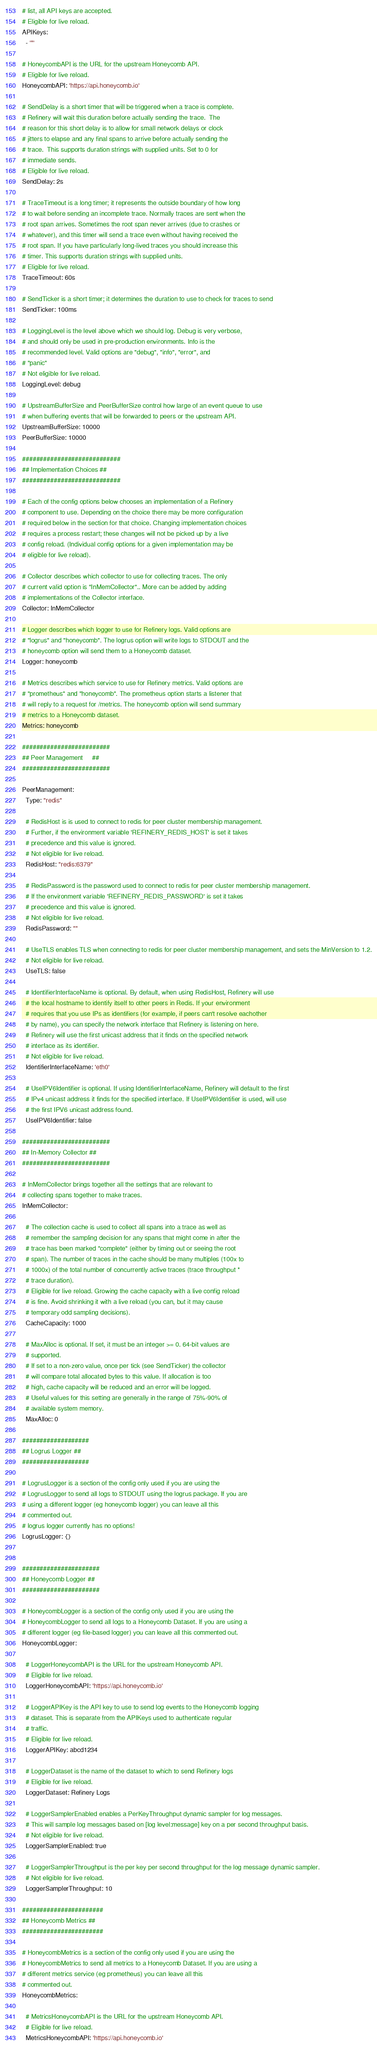Convert code to text. <code><loc_0><loc_0><loc_500><loc_500><_YAML_># list, all API keys are accepted.
# Eligible for live reload.
APIKeys:
  - '*'

# HoneycombAPI is the URL for the upstream Honeycomb API.
# Eligible for live reload.
HoneycombAPI: 'https://api.honeycomb.io'

# SendDelay is a short timer that will be triggered when a trace is complete.
# Refinery will wait this duration before actually sending the trace.  The
# reason for this short delay is to allow for small network delays or clock
# jitters to elapse and any final spans to arrive before actually sending the
# trace.  This supports duration strings with supplied units. Set to 0 for
# immediate sends.
# Eligible for live reload.
SendDelay: 2s

# TraceTimeout is a long timer; it represents the outside boundary of how long
# to wait before sending an incomplete trace. Normally traces are sent when the
# root span arrives. Sometimes the root span never arrives (due to crashes or
# whatever), and this timer will send a trace even without having received the
# root span. If you have particularly long-lived traces you should increase this
# timer. This supports duration strings with supplied units.
# Eligible for live reload.
TraceTimeout: 60s

# SendTicker is a short timer; it determines the duration to use to check for traces to send
SendTicker: 100ms

# LoggingLevel is the level above which we should log. Debug is very verbose,
# and should only be used in pre-production environments. Info is the
# recommended level. Valid options are "debug", "info", "error", and
# "panic"
# Not eligible for live reload.
LoggingLevel: debug

# UpstreamBufferSize and PeerBufferSize control how large of an event queue to use
# when buffering events that will be forwarded to peers or the upstream API.
UpstreamBufferSize: 10000
PeerBufferSize: 10000

############################
## Implementation Choices ##
############################

# Each of the config options below chooses an implementation of a Refinery
# component to use. Depending on the choice there may be more configuration
# required below in the section for that choice. Changing implementation choices
# requires a process restart; these changes will not be picked up by a live
# config reload. (Individual config options for a given implementation may be
# eligible for live reload).

# Collector describes which collector to use for collecting traces. The only
# current valid option is "InMemCollector".. More can be added by adding
# implementations of the Collector interface.
Collector: InMemCollector

# Logger describes which logger to use for Refinery logs. Valid options are
# "logrus" and "honeycomb". The logrus option will write logs to STDOUT and the
# honeycomb option will send them to a Honeycomb dataset.
Logger: honeycomb

# Metrics describes which service to use for Refinery metrics. Valid options are
# "prometheus" and "honeycomb". The prometheus option starts a listener that
# will reply to a request for /metrics. The honeycomb option will send summary
# metrics to a Honeycomb dataset.
Metrics: honeycomb

#########################
## Peer Management     ##
#########################

PeerManagement:
  Type: "redis"

  # RedisHost is is used to connect to redis for peer cluster membership management.
  # Further, if the environment variable 'REFINERY_REDIS_HOST' is set it takes
  # precedence and this value is ignored.
  # Not eligible for live reload.
  RedisHost: "redis:6379"

  # RedisPassword is the password used to connect to redis for peer cluster membership management.
  # If the environment variable 'REFINERY_REDIS_PASSWORD' is set it takes
  # precedence and this value is ignored.
  # Not eligible for live reload.
  RedisPassword: ""

  # UseTLS enables TLS when connecting to redis for peer cluster membership management, and sets the MinVersion to 1.2.
  # Not eligible for live reload.
  UseTLS: false

  # IdentifierInterfaceName is optional. By default, when using RedisHost, Refinery will use
  # the local hostname to identify itself to other peers in Redis. If your environment
  # requires that you use IPs as identifiers (for example, if peers can't resolve eachother
  # by name), you can specify the network interface that Refinery is listening on here.
  # Refinery will use the first unicast address that it finds on the specified network
  # interface as its identifier.
  # Not eligible for live reload.
  IdentifierInterfaceName: 'eth0'

  # UseIPV6Identifier is optional. If using IdentifierInterfaceName, Refinery will default to the first
  # IPv4 unicast address it finds for the specified interface. If UseIPV6Identifier is used, will use
  # the first IPV6 unicast address found.
  UseIPV6Identifier: false

#########################
## In-Memory Collector ##
#########################

# InMemCollector brings together all the settings that are relevant to
# collecting spans together to make traces.
InMemCollector:

  # The collection cache is used to collect all spans into a trace as well as
  # remember the sampling decision for any spans that might come in after the
  # trace has been marked "complete" (either by timing out or seeing the root
  # span). The number of traces in the cache should be many multiples (100x to
  # 1000x) of the total number of concurrently active traces (trace throughput *
  # trace duration).
  # Eligible for live reload. Growing the cache capacity with a live config reload
  # is fine. Avoid shrinking it with a live reload (you can, but it may cause
  # temporary odd sampling decisions).
  CacheCapacity: 1000

  # MaxAlloc is optional. If set, it must be an integer >= 0. 64-bit values are
  # supported.
  # If set to a non-zero value, once per tick (see SendTicker) the collector
  # will compare total allocated bytes to this value. If allocation is too
  # high, cache capacity will be reduced and an error will be logged.
  # Useful values for this setting are generally in the range of 75%-90% of
  # available system memory.
  MaxAlloc: 0

###################
## Logrus Logger ##
###################

# LogrusLogger is a section of the config only used if you are using the
# LogrusLogger to send all logs to STDOUT using the logrus package. If you are
# using a different logger (eg honeycomb logger) you can leave all this
# commented out.
# logrus logger currently has no options!
LogrusLogger: {}


######################
## Honeycomb Logger ##
######################

# HoneycombLogger is a section of the config only used if you are using the
# HoneycombLogger to send all logs to a Honeycomb Dataset. If you are using a
# different logger (eg file-based logger) you can leave all this commented out.
HoneycombLogger:

  # LoggerHoneycombAPI is the URL for the upstream Honeycomb API.
  # Eligible for live reload.
  LoggerHoneycombAPI: 'https://api.honeycomb.io'

  # LoggerAPIKey is the API key to use to send log events to the Honeycomb logging
  # dataset. This is separate from the APIKeys used to authenticate regular
  # traffic.
  # Eligible for live reload.
  LoggerAPIKey: abcd1234

  # LoggerDataset is the name of the dataset to which to send Refinery logs
  # Eligible for live reload.
  LoggerDataset: Refinery Logs

  # LoggerSamplerEnabled enables a PerKeyThroughput dynamic sampler for log messages.
  # This will sample log messages based on [log level:message] key on a per second throughput basis.
  # Not eligible for live reload.
  LoggerSamplerEnabled: true

  # LoggerSamplerThroughput is the per key per second throughput for the log message dynamic sampler.
  # Not eligible for live reload.
  LoggerSamplerThroughput: 10

#######################
## Honeycomb Metrics ##
#######################

# HoneycombMetrics is a section of the config only used if you are using the
# HoneycombMetrics to send all metrics to a Honeycomb Dataset. If you are using a
# different metrics service (eg prometheus) you can leave all this
# commented out.
HoneycombMetrics:

  # MetricsHoneycombAPI is the URL for the upstream Honeycomb API.
  # Eligible for live reload.
  MetricsHoneycombAPI: 'https://api.honeycomb.io'
</code> 